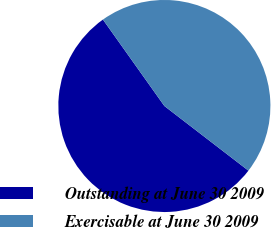Convert chart to OTSL. <chart><loc_0><loc_0><loc_500><loc_500><pie_chart><fcel>Outstanding at June 30 2009<fcel>Exercisable at June 30 2009<nl><fcel>54.73%<fcel>45.27%<nl></chart> 